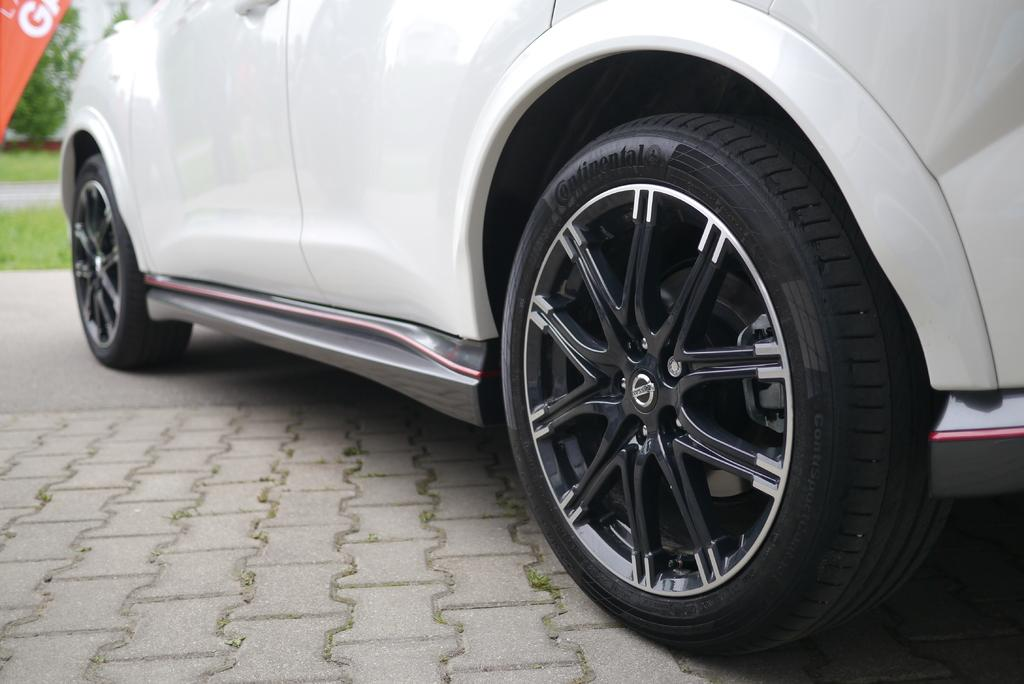What type of vehicle is on the road in the image? There is a white car on the road in the image. What can be seen in the background of the image? There is a building in the background of the image. What is located on the left side of the image? There are posters, plants, and grass on the left side of the image. Where is the swing located in the image? There is no swing present in the image. What type of books can be seen on the left side of the image? There are no books visible in the image. 